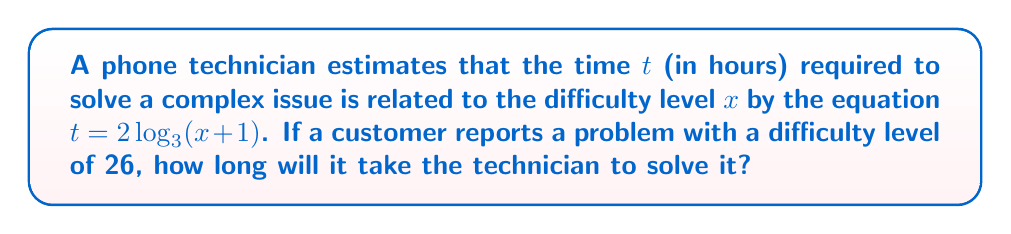Help me with this question. Let's approach this step-by-step:

1) We're given the equation $t = 2\log_3(x+1)$, where:
   $t$ is the time in hours
   $x$ is the difficulty level

2) We're told that the difficulty level $x = 26$

3) Let's substitute this into our equation:
   $t = 2\log_3(26+1)$
   $t = 2\log_3(27)$

4) Now, we need to evaluate $\log_3(27)$:
   $3^3 = 27$, so $\log_3(27) = 3$

5) Substituting this back into our equation:
   $t = 2(3) = 6$

Therefore, it will take the technician 6 hours to solve this complex issue.
Answer: 6 hours 